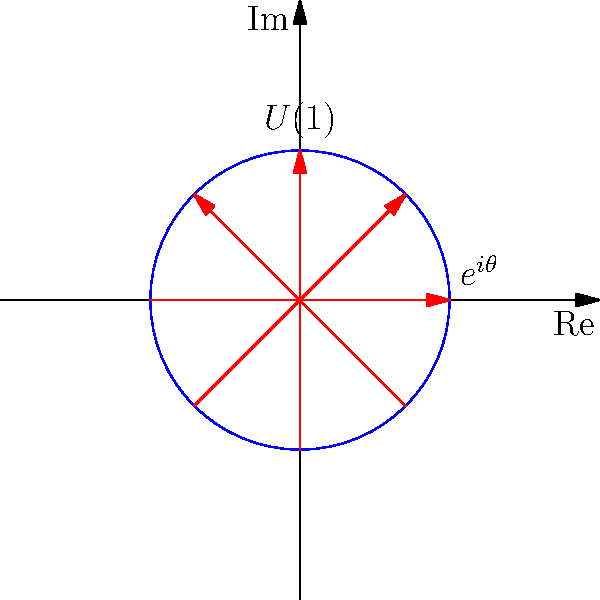In the context of quantum mechanics and group theory, what does this diagram represent, and how does it relate to the conservation of electric charge? This diagram represents the U(1) symmetry group, which is crucial in understanding the conservation of electric charge in quantum mechanics. Here's a step-by-step explanation:

1. The circle in the diagram represents the complex plane, where each point on the circle corresponds to a complex number of the form $e^{i\theta}$.

2. The arrows indicate different rotations in the complex plane. These rotations form the U(1) group, which is the group of unitary 1x1 matrices.

3. In quantum mechanics, the wave function of a charged particle transforms under the U(1) group as:
   $$\psi \rightarrow e^{i\alpha}\psi$$
   where $\alpha$ is a real number.

4. This transformation leaves the probability density $|\psi|^2$ unchanged, which is a key feature of symmetry in quantum mechanics.

5. According to Noether's theorem, every continuous symmetry of a physical system corresponds to a conserved quantity. In this case, the U(1) symmetry corresponds to the conservation of electric charge.

6. The invariance of the laws of physics under this U(1) transformation implies that electric charge must be conserved in all interactions.

7. This symmetry is fundamental in quantum electrodynamics and plays a crucial role in the Standard Model of particle physics.

In summary, this diagram visualizes the U(1) symmetry group, which, through Noether's theorem, directly relates to the conservation of electric charge in quantum mechanics.
Answer: U(1) symmetry group representing charge conservation 